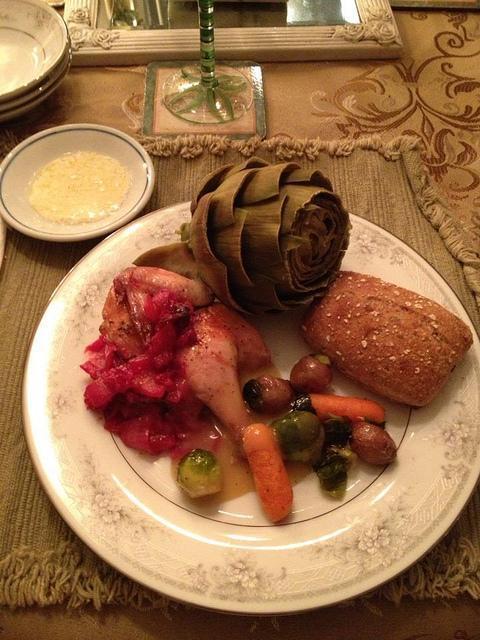How many bowls are in the photo?
Give a very brief answer. 2. 